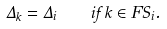Convert formula to latex. <formula><loc_0><loc_0><loc_500><loc_500>\Delta _ { k } = \Delta _ { i } \quad i f \, k \in F S _ { i } .</formula> 